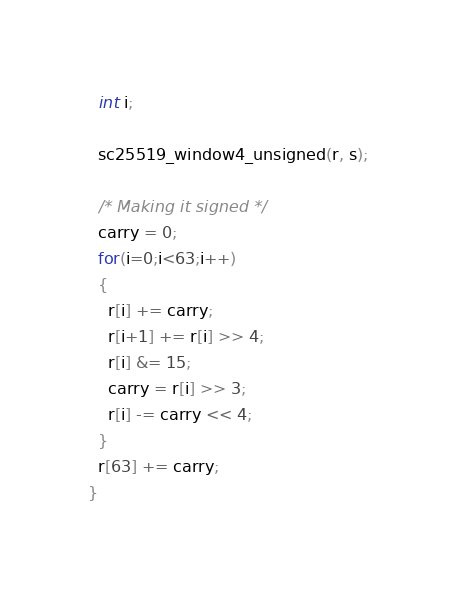Convert code to text. <code><loc_0><loc_0><loc_500><loc_500><_C_>  int i;

  sc25519_window4_unsigned(r, s);

  /* Making it signed */
  carry = 0;
  for(i=0;i<63;i++)
  {
    r[i] += carry;
    r[i+1] += r[i] >> 4;
    r[i] &= 15;
    carry = r[i] >> 3;
    r[i] -= carry << 4;
  }
  r[63] += carry;
}

</code> 